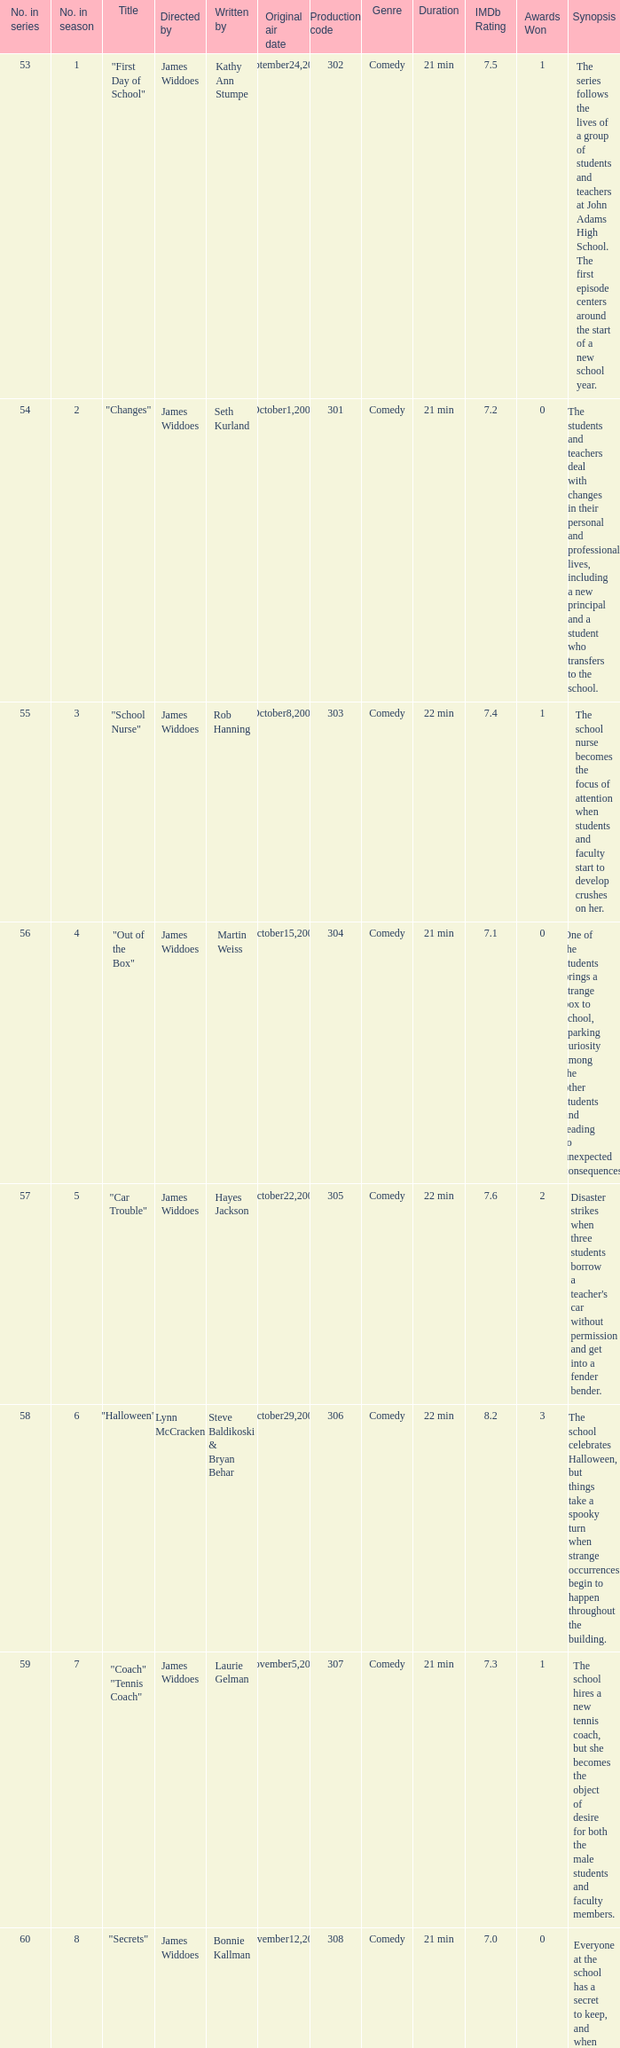How many production codes are there for "the sub"? 1.0. 